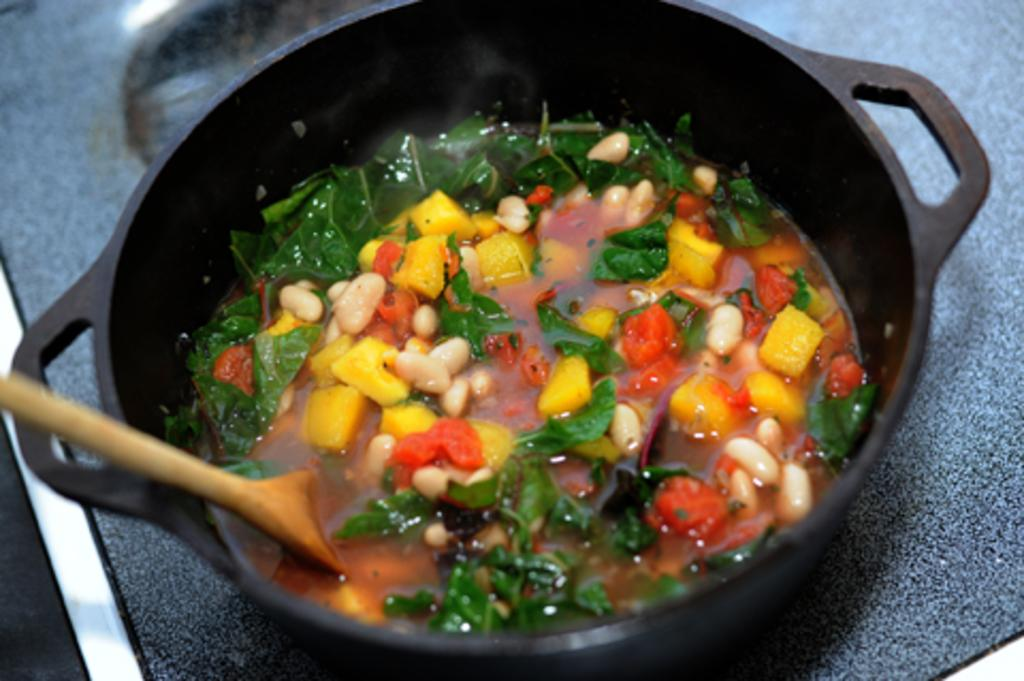What type of food is in the bowl in the image? There is vegetable soup in the image. What color is the bowl containing the soup? The bowl is black. What utensil is present in the image? There is a spoon in the image. What color is the surface on which the bowl is placed? The bowl is on a blue surface. What type of rhythm can be heard in the background of the image? There is no audible rhythm present in the image, as it is a still image of vegetable soup in a bowl. 